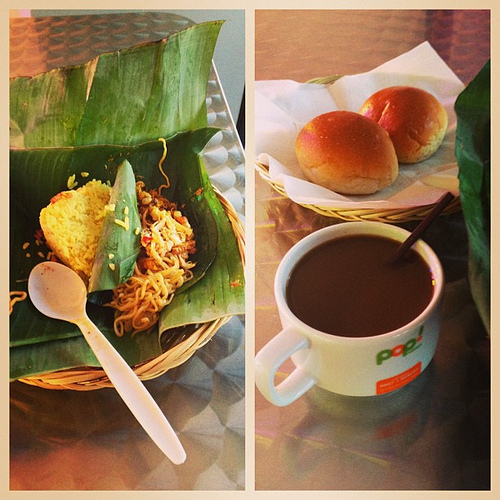What food is to the left of the coffee? Nestled to the left of the comforting beverage, the noodles await to satisfy your hunger with every flavorful twirl. 